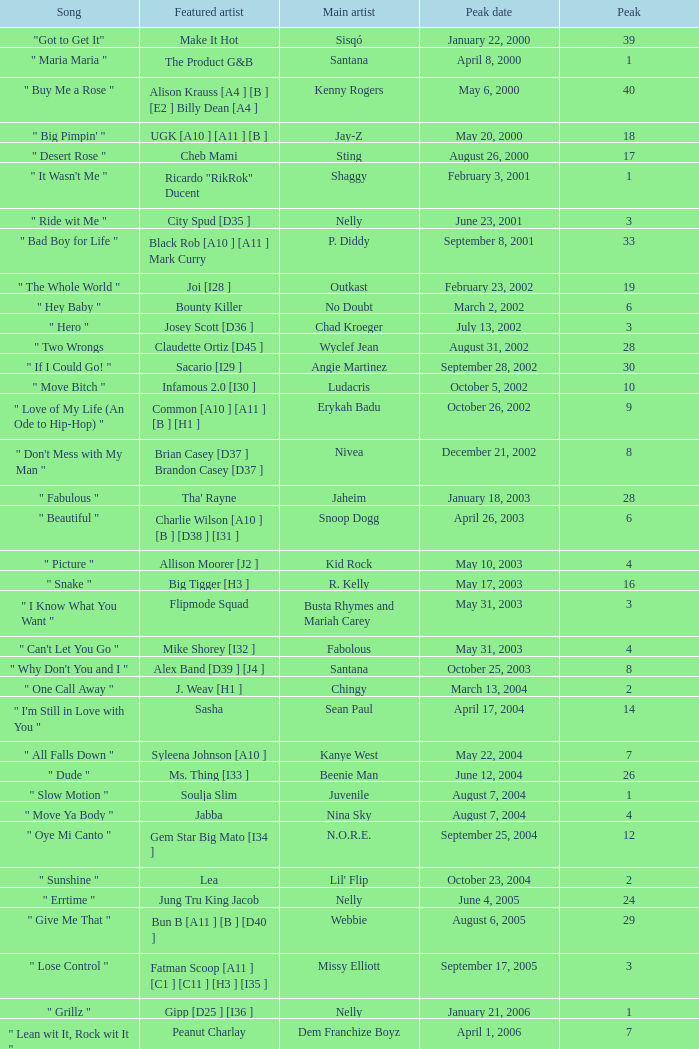What was the peak date of Kelis's song? August 6, 2006. 